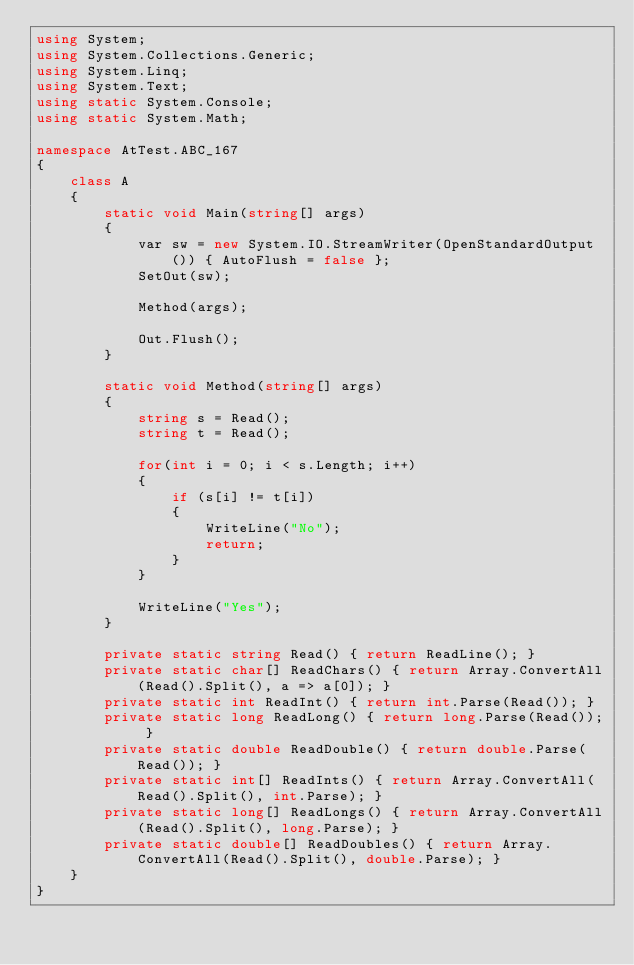Convert code to text. <code><loc_0><loc_0><loc_500><loc_500><_C#_>using System;
using System.Collections.Generic;
using System.Linq;
using System.Text;
using static System.Console;
using static System.Math;

namespace AtTest.ABC_167
{
    class A
    {
        static void Main(string[] args)
        {
            var sw = new System.IO.StreamWriter(OpenStandardOutput()) { AutoFlush = false };
            SetOut(sw);

            Method(args);

            Out.Flush();
        }

        static void Method(string[] args)
        {
            string s = Read();
            string t = Read();

            for(int i = 0; i < s.Length; i++)
            {
                if (s[i] != t[i])
                {
                    WriteLine("No");
                    return;
                }
            }

            WriteLine("Yes");
        }

        private static string Read() { return ReadLine(); }
        private static char[] ReadChars() { return Array.ConvertAll(Read().Split(), a => a[0]); }
        private static int ReadInt() { return int.Parse(Read()); }
        private static long ReadLong() { return long.Parse(Read()); }
        private static double ReadDouble() { return double.Parse(Read()); }
        private static int[] ReadInts() { return Array.ConvertAll(Read().Split(), int.Parse); }
        private static long[] ReadLongs() { return Array.ConvertAll(Read().Split(), long.Parse); }
        private static double[] ReadDoubles() { return Array.ConvertAll(Read().Split(), double.Parse); }
    }
}
</code> 